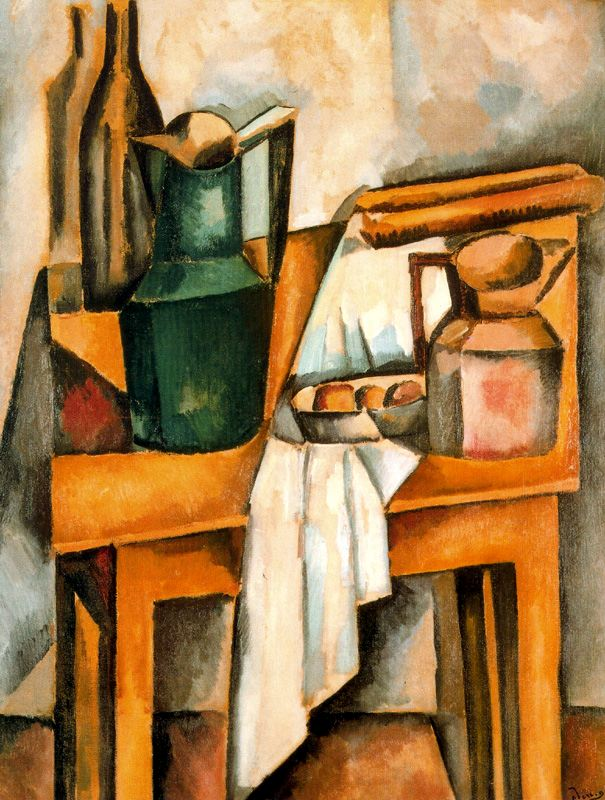Explain the visual content of the image in great detail. The image is a captivating representation of a still life scene, painted in the distinctive Cubist art style. The central focus is a table, adorned with a green vase, a blue book, and a pink jar. The table is draped with a white cloth, adding a sense of depth and texture to the composition. In the background, a brown chair subtly complements the scene, providing a sense of space and perspective. The color palette is predominantly muted, with the green vase and the pink jar serving as vibrant exceptions that draw the viewer's eye. The painting bears the signature "Dufy" in the lower right corner, hinting at the artist's identity. 